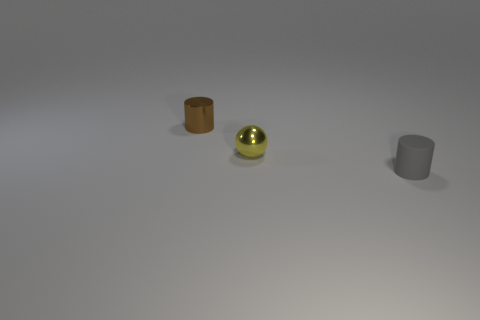Add 2 large metal cylinders. How many objects exist? 5 Subtract all spheres. How many objects are left? 2 Subtract all cyan matte balls. Subtract all yellow metallic spheres. How many objects are left? 2 Add 3 metallic balls. How many metallic balls are left? 4 Add 3 small yellow spheres. How many small yellow spheres exist? 4 Subtract 0 blue cubes. How many objects are left? 3 